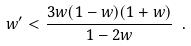Convert formula to latex. <formula><loc_0><loc_0><loc_500><loc_500>w ^ { \prime } < \frac { 3 w ( 1 - w ) ( 1 + w ) } { 1 - 2 w } \ .</formula> 